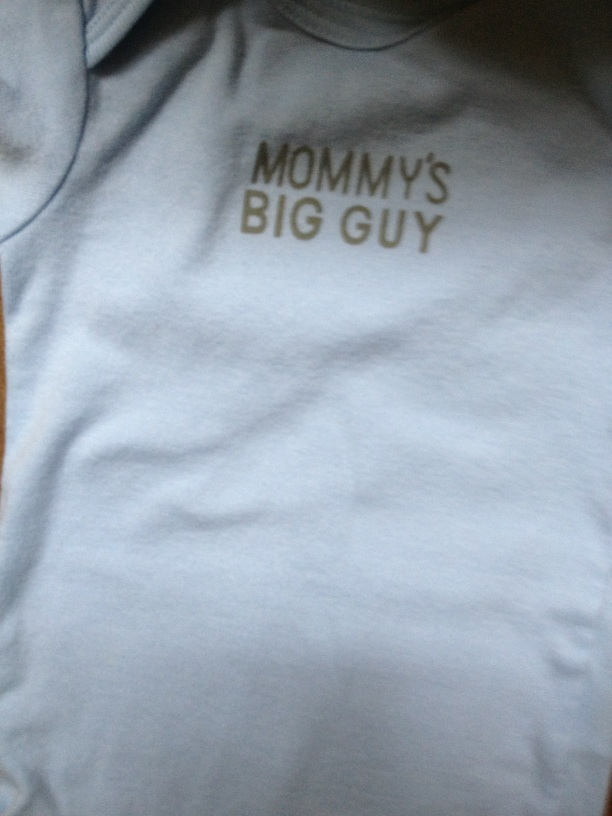Imagine a scenario where this shirt becomes a famous fashion trend. Imagine this adorable shirt becoming the latest fashion trend among babies! Parents everywhere start dressing their infants in shirts with similar phrases, celebrating their little ones. Social media is flooded with pictures of smiling babies proudly wearing 'Mommy's Big Guy,' 'Daddy's Little Champ,' and other charming endearments. Celebrities join in on the trend, sharing photos of their own babies in these shirts, making it a global sensation! 